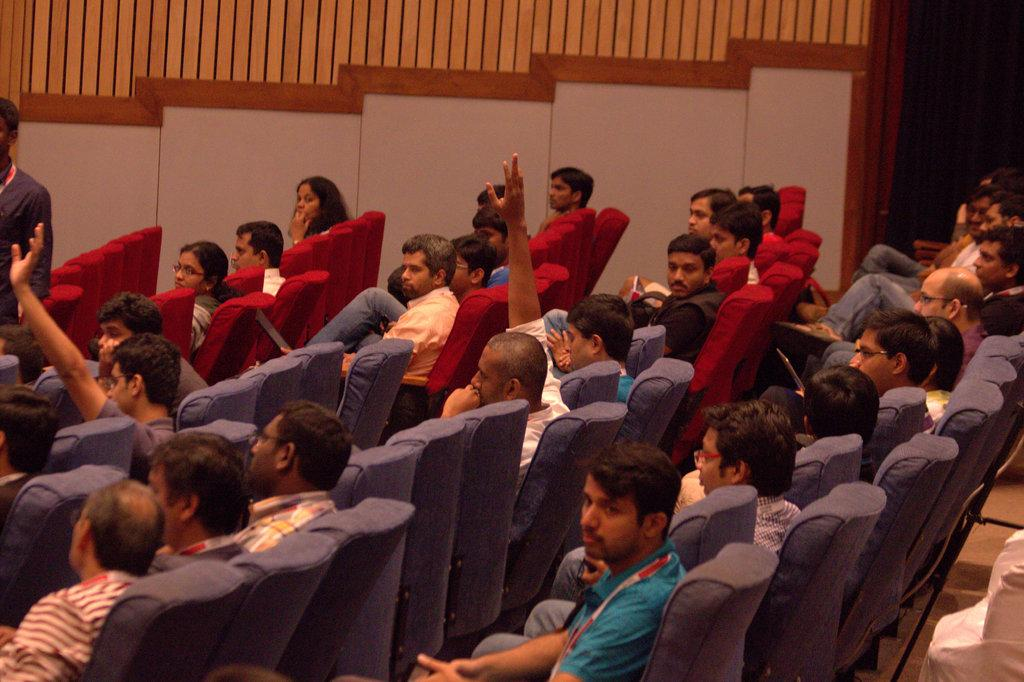What are the people in the image doing? The people in the image are sitting on chairs. Can you describe the position of the person on the left side of the image? There is a person standing on the left side of the image. What can be seen in the background of the image? A wall is visible in the background of the image. Is there any quicksand present in the image? No, there is no quicksand present in the image. How many owls can be seen in the image? There are no owls present in the image. 